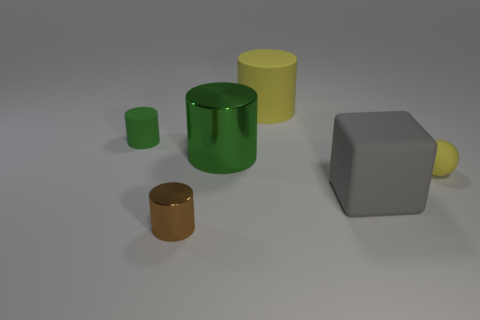Add 3 tiny brown things. How many objects exist? 9 Subtract all cylinders. How many objects are left? 2 Add 5 yellow matte things. How many yellow matte things exist? 7 Subtract 0 purple spheres. How many objects are left? 6 Subtract all green cylinders. Subtract all yellow things. How many objects are left? 2 Add 4 large yellow rubber things. How many large yellow rubber things are left? 5 